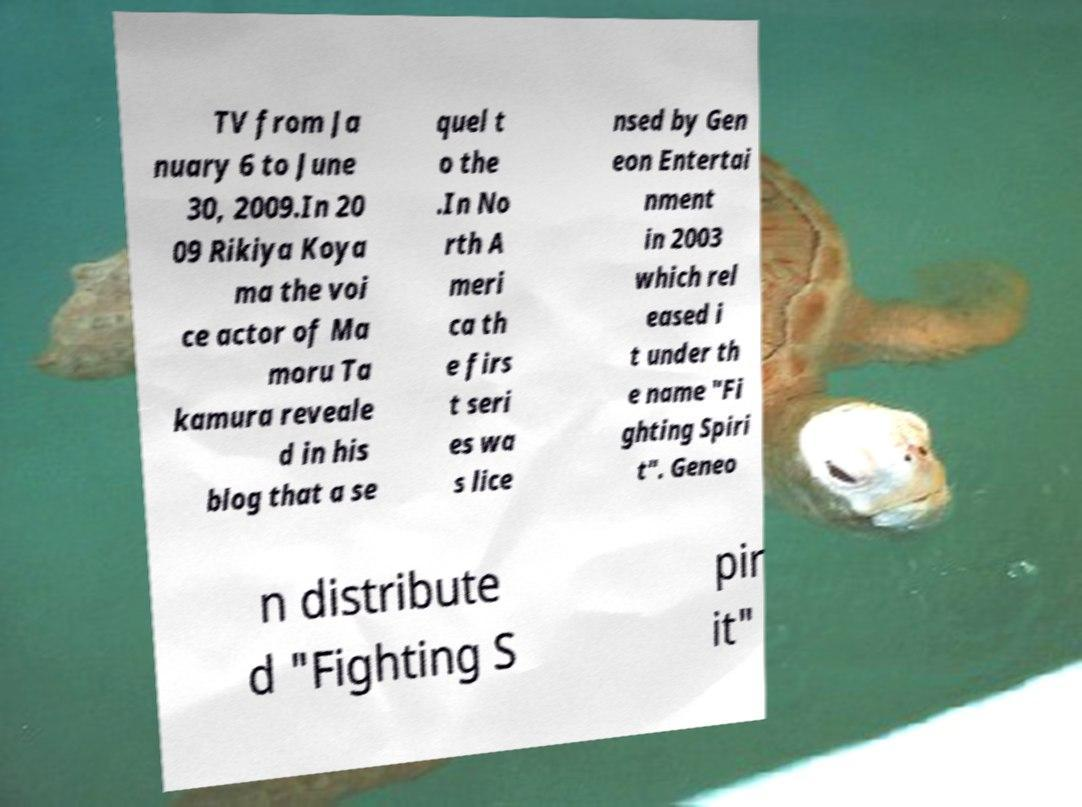Please read and relay the text visible in this image. What does it say? TV from Ja nuary 6 to June 30, 2009.In 20 09 Rikiya Koya ma the voi ce actor of Ma moru Ta kamura reveale d in his blog that a se quel t o the .In No rth A meri ca th e firs t seri es wa s lice nsed by Gen eon Entertai nment in 2003 which rel eased i t under th e name "Fi ghting Spiri t". Geneo n distribute d "Fighting S pir it" 